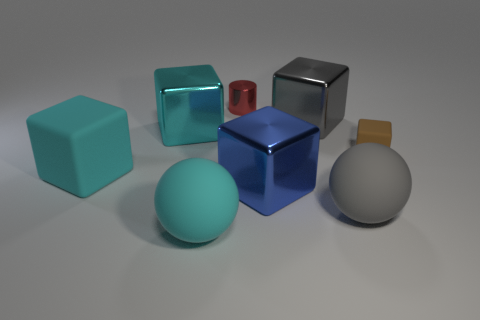How many large gray rubber objects are the same shape as the cyan metal thing?
Your answer should be compact. 0. What is the size of the cyan cube that is made of the same material as the gray block?
Offer a terse response. Large. What is the cyan thing that is on the right side of the large rubber cube and in front of the tiny rubber thing made of?
Give a very brief answer. Rubber. What number of cylinders are the same size as the blue shiny thing?
Your answer should be compact. 0. There is a small brown object that is the same shape as the cyan shiny object; what is it made of?
Provide a succinct answer. Rubber. How many things are shiny objects that are right of the big cyan metallic cube or large cyan matte objects that are on the left side of the cyan shiny cube?
Provide a short and direct response. 4. Is the shape of the large blue metal object the same as the big matte thing that is behind the gray matte thing?
Your answer should be very brief. Yes. What shape is the metallic object on the left side of the small thing that is behind the small thing on the right side of the blue metallic block?
Your response must be concise. Cube. What number of other things are made of the same material as the big gray sphere?
Make the answer very short. 3. What number of things are metal objects in front of the big cyan metal block or brown blocks?
Make the answer very short. 2. 